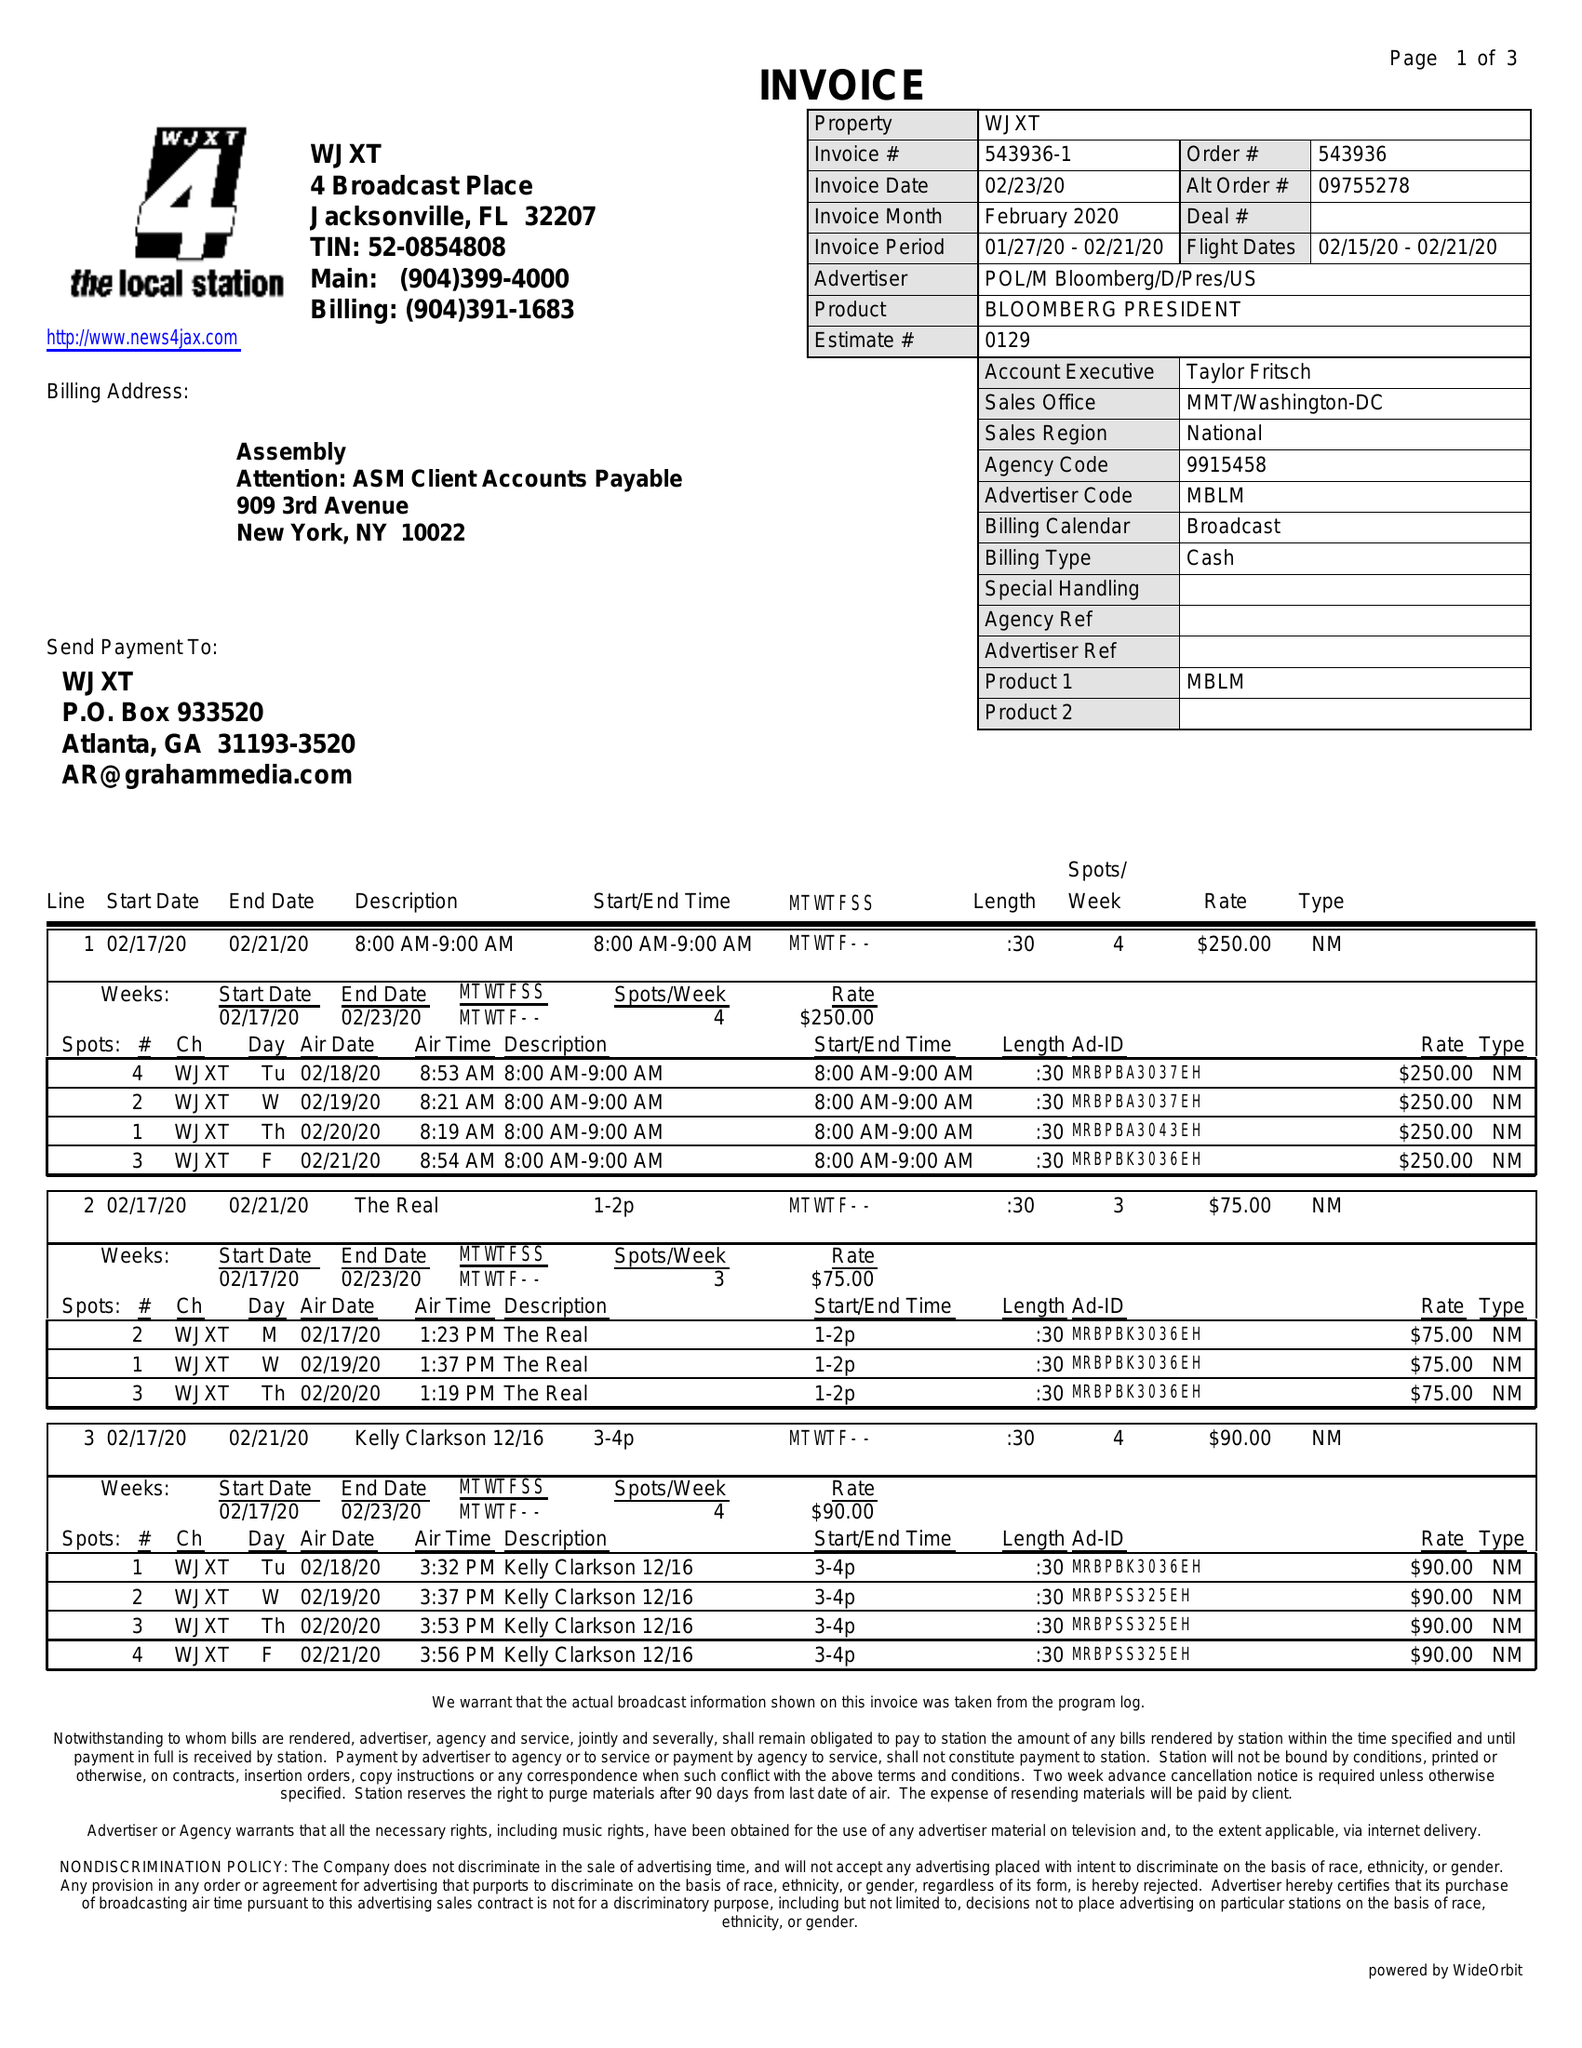What is the value for the advertiser?
Answer the question using a single word or phrase. POL/MBLOOMBERG/D/PRES/US 